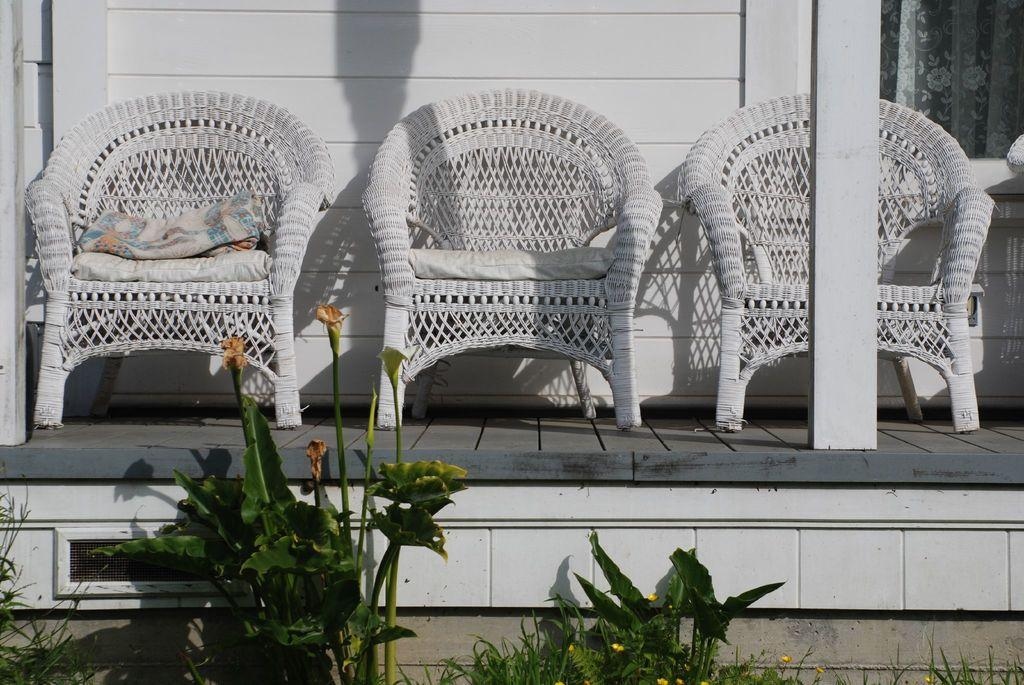What type of furniture is present in the image? There are chairs in the image. What feature do the chairs have? The chairs have cushions on them. What can be seen below the chairs? There are plants below the chairs. What is visible in the background of the image? There is a wall and a curtain in the background of the image. What songs are being sung by the duck in the image? There is no duck present in the image, so no songs can be heard or seen. 